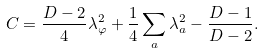Convert formula to latex. <formula><loc_0><loc_0><loc_500><loc_500>C = \frac { D - 2 } { 4 } \lambda _ { \varphi } ^ { 2 } + \frac { 1 } { 4 } \sum _ { a } \lambda _ { a } ^ { 2 } - \frac { D - 1 } { D - 2 } .</formula> 